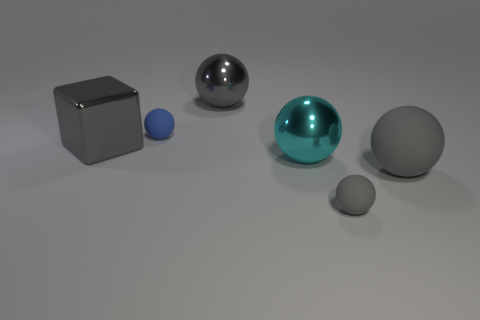How many gray spheres must be subtracted to get 1 gray spheres? 2 Subtract all yellow cubes. How many gray spheres are left? 3 Subtract all big cyan metallic balls. How many balls are left? 4 Subtract all blue balls. How many balls are left? 4 Subtract all green balls. Subtract all brown cylinders. How many balls are left? 5 Add 1 tiny purple balls. How many objects exist? 7 Subtract all cubes. How many objects are left? 5 Add 5 cyan balls. How many cyan balls are left? 6 Add 1 brown matte cubes. How many brown matte cubes exist? 1 Subtract 0 purple cylinders. How many objects are left? 6 